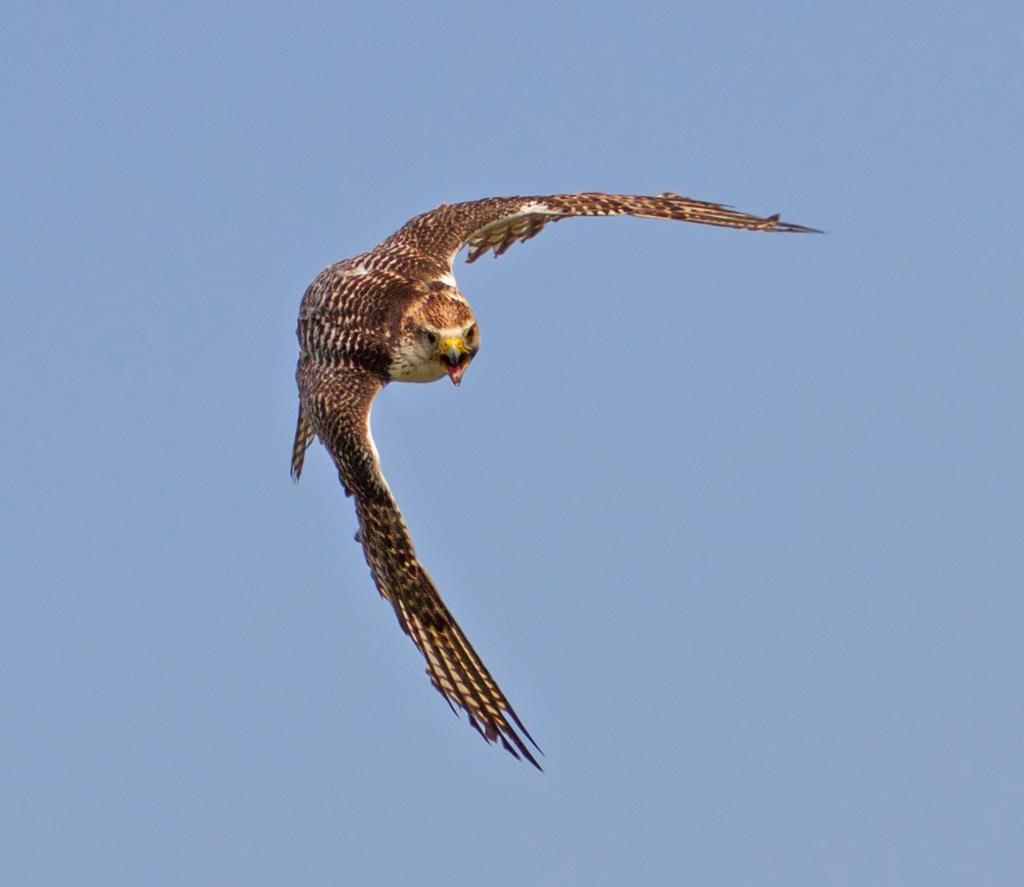Describe this image in one or two sentences. In this picture we can see a bird flying in the sky. 